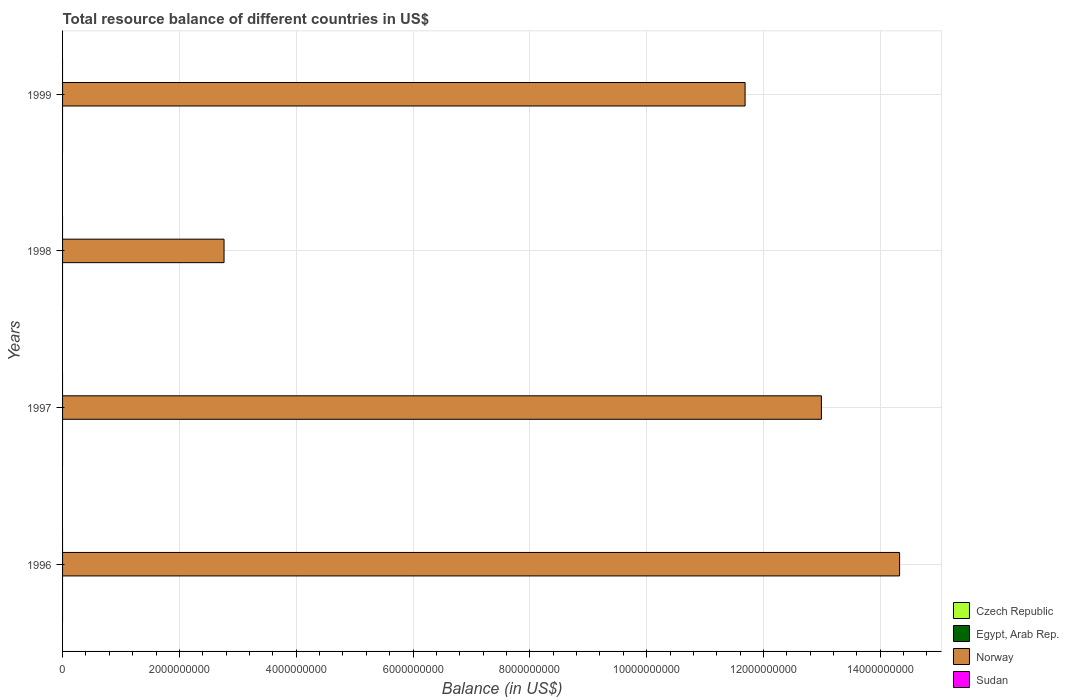How many different coloured bars are there?
Provide a short and direct response. 1. Are the number of bars per tick equal to the number of legend labels?
Make the answer very short. No. How many bars are there on the 4th tick from the bottom?
Keep it short and to the point. 1. What is the total resource balance in Egypt, Arab Rep. in 1997?
Your answer should be compact. 0. Across all years, what is the maximum total resource balance in Norway?
Provide a succinct answer. 1.43e+1. Across all years, what is the minimum total resource balance in Sudan?
Your answer should be very brief. 0. In which year was the total resource balance in Norway maximum?
Provide a short and direct response. 1996. What is the difference between the total resource balance in Norway in 1996 and that in 1998?
Offer a very short reply. 1.16e+1. What is the difference between the total resource balance in Sudan in 1996 and the total resource balance in Norway in 1997?
Offer a very short reply. -1.30e+1. What is the average total resource balance in Egypt, Arab Rep. per year?
Your answer should be compact. 0. What is the ratio of the total resource balance in Norway in 1998 to that in 1999?
Offer a terse response. 0.24. Is the total resource balance in Norway in 1996 less than that in 1999?
Provide a succinct answer. No. What is the difference between the highest and the second highest total resource balance in Norway?
Provide a succinct answer. 1.34e+09. What is the difference between the highest and the lowest total resource balance in Norway?
Your answer should be compact. 1.16e+1. In how many years, is the total resource balance in Czech Republic greater than the average total resource balance in Czech Republic taken over all years?
Keep it short and to the point. 0. Is it the case that in every year, the sum of the total resource balance in Sudan and total resource balance in Egypt, Arab Rep. is greater than the total resource balance in Czech Republic?
Make the answer very short. No. Are all the bars in the graph horizontal?
Your answer should be very brief. Yes. Where does the legend appear in the graph?
Keep it short and to the point. Bottom right. What is the title of the graph?
Ensure brevity in your answer.  Total resource balance of different countries in US$. Does "Bangladesh" appear as one of the legend labels in the graph?
Give a very brief answer. No. What is the label or title of the X-axis?
Offer a very short reply. Balance (in US$). What is the label or title of the Y-axis?
Your response must be concise. Years. What is the Balance (in US$) in Czech Republic in 1996?
Your response must be concise. 0. What is the Balance (in US$) in Egypt, Arab Rep. in 1996?
Keep it short and to the point. 0. What is the Balance (in US$) in Norway in 1996?
Provide a succinct answer. 1.43e+1. What is the Balance (in US$) in Sudan in 1996?
Ensure brevity in your answer.  0. What is the Balance (in US$) of Egypt, Arab Rep. in 1997?
Offer a very short reply. 0. What is the Balance (in US$) of Norway in 1997?
Provide a succinct answer. 1.30e+1. What is the Balance (in US$) of Sudan in 1997?
Keep it short and to the point. 0. What is the Balance (in US$) in Czech Republic in 1998?
Provide a succinct answer. 0. What is the Balance (in US$) in Egypt, Arab Rep. in 1998?
Your response must be concise. 0. What is the Balance (in US$) in Norway in 1998?
Give a very brief answer. 2.76e+09. What is the Balance (in US$) of Sudan in 1998?
Your answer should be very brief. 0. What is the Balance (in US$) of Czech Republic in 1999?
Your response must be concise. 0. What is the Balance (in US$) of Egypt, Arab Rep. in 1999?
Give a very brief answer. 0. What is the Balance (in US$) of Norway in 1999?
Provide a short and direct response. 1.17e+1. What is the Balance (in US$) of Sudan in 1999?
Ensure brevity in your answer.  0. Across all years, what is the maximum Balance (in US$) in Norway?
Give a very brief answer. 1.43e+1. Across all years, what is the minimum Balance (in US$) in Norway?
Ensure brevity in your answer.  2.76e+09. What is the total Balance (in US$) in Norway in the graph?
Ensure brevity in your answer.  4.18e+1. What is the difference between the Balance (in US$) in Norway in 1996 and that in 1997?
Your answer should be very brief. 1.34e+09. What is the difference between the Balance (in US$) in Norway in 1996 and that in 1998?
Offer a very short reply. 1.16e+1. What is the difference between the Balance (in US$) of Norway in 1996 and that in 1999?
Your answer should be compact. 2.65e+09. What is the difference between the Balance (in US$) in Norway in 1997 and that in 1998?
Give a very brief answer. 1.02e+1. What is the difference between the Balance (in US$) in Norway in 1997 and that in 1999?
Offer a very short reply. 1.31e+09. What is the difference between the Balance (in US$) in Norway in 1998 and that in 1999?
Provide a succinct answer. -8.92e+09. What is the average Balance (in US$) in Norway per year?
Offer a terse response. 1.04e+1. What is the ratio of the Balance (in US$) of Norway in 1996 to that in 1997?
Your response must be concise. 1.1. What is the ratio of the Balance (in US$) of Norway in 1996 to that in 1998?
Your answer should be very brief. 5.18. What is the ratio of the Balance (in US$) in Norway in 1996 to that in 1999?
Keep it short and to the point. 1.23. What is the ratio of the Balance (in US$) of Norway in 1997 to that in 1998?
Your answer should be compact. 4.7. What is the ratio of the Balance (in US$) in Norway in 1997 to that in 1999?
Your answer should be compact. 1.11. What is the ratio of the Balance (in US$) of Norway in 1998 to that in 1999?
Give a very brief answer. 0.24. What is the difference between the highest and the second highest Balance (in US$) of Norway?
Offer a terse response. 1.34e+09. What is the difference between the highest and the lowest Balance (in US$) in Norway?
Keep it short and to the point. 1.16e+1. 